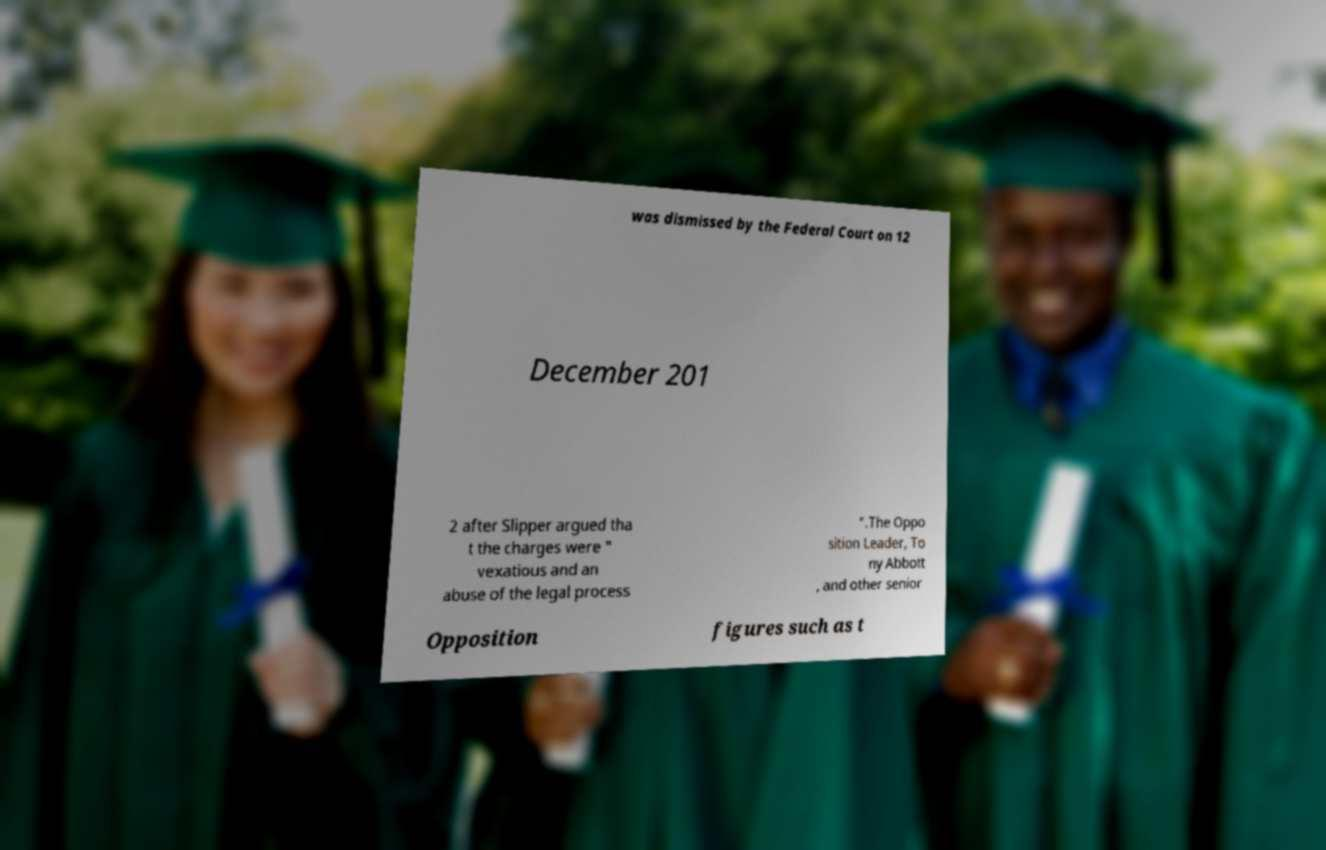Could you extract and type out the text from this image? was dismissed by the Federal Court on 12 December 201 2 after Slipper argued tha t the charges were " vexatious and an abuse of the legal process ".The Oppo sition Leader, To ny Abbott , and other senior Opposition figures such as t 